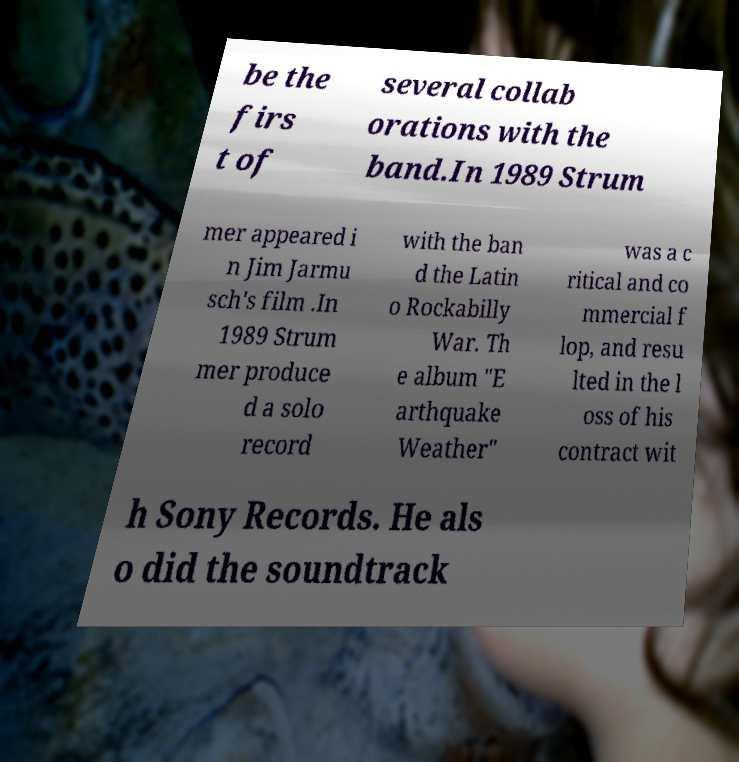Could you extract and type out the text from this image? be the firs t of several collab orations with the band.In 1989 Strum mer appeared i n Jim Jarmu sch's film .In 1989 Strum mer produce d a solo record with the ban d the Latin o Rockabilly War. Th e album "E arthquake Weather" was a c ritical and co mmercial f lop, and resu lted in the l oss of his contract wit h Sony Records. He als o did the soundtrack 